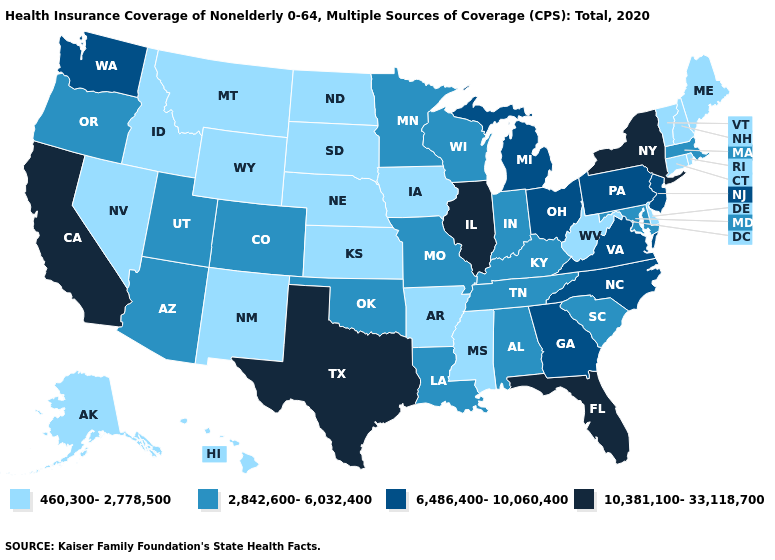Does Minnesota have the highest value in the USA?
Short answer required. No. Name the states that have a value in the range 6,486,400-10,060,400?
Concise answer only. Georgia, Michigan, New Jersey, North Carolina, Ohio, Pennsylvania, Virginia, Washington. Name the states that have a value in the range 6,486,400-10,060,400?
Give a very brief answer. Georgia, Michigan, New Jersey, North Carolina, Ohio, Pennsylvania, Virginia, Washington. How many symbols are there in the legend?
Quick response, please. 4. What is the lowest value in states that border Nebraska?
Keep it brief. 460,300-2,778,500. What is the highest value in the MidWest ?
Answer briefly. 10,381,100-33,118,700. Name the states that have a value in the range 460,300-2,778,500?
Write a very short answer. Alaska, Arkansas, Connecticut, Delaware, Hawaii, Idaho, Iowa, Kansas, Maine, Mississippi, Montana, Nebraska, Nevada, New Hampshire, New Mexico, North Dakota, Rhode Island, South Dakota, Vermont, West Virginia, Wyoming. What is the value of New Jersey?
Keep it brief. 6,486,400-10,060,400. Does South Carolina have the highest value in the South?
Answer briefly. No. Does Arizona have the lowest value in the USA?
Answer briefly. No. Among the states that border Maryland , which have the highest value?
Give a very brief answer. Pennsylvania, Virginia. Name the states that have a value in the range 6,486,400-10,060,400?
Quick response, please. Georgia, Michigan, New Jersey, North Carolina, Ohio, Pennsylvania, Virginia, Washington. Name the states that have a value in the range 2,842,600-6,032,400?
Answer briefly. Alabama, Arizona, Colorado, Indiana, Kentucky, Louisiana, Maryland, Massachusetts, Minnesota, Missouri, Oklahoma, Oregon, South Carolina, Tennessee, Utah, Wisconsin. What is the value of Illinois?
Give a very brief answer. 10,381,100-33,118,700. Which states have the lowest value in the USA?
Short answer required. Alaska, Arkansas, Connecticut, Delaware, Hawaii, Idaho, Iowa, Kansas, Maine, Mississippi, Montana, Nebraska, Nevada, New Hampshire, New Mexico, North Dakota, Rhode Island, South Dakota, Vermont, West Virginia, Wyoming. 